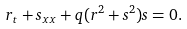<formula> <loc_0><loc_0><loc_500><loc_500>r _ { t } + s _ { x x } + q ( r ^ { 2 } + s ^ { 2 } ) s = 0 .</formula> 